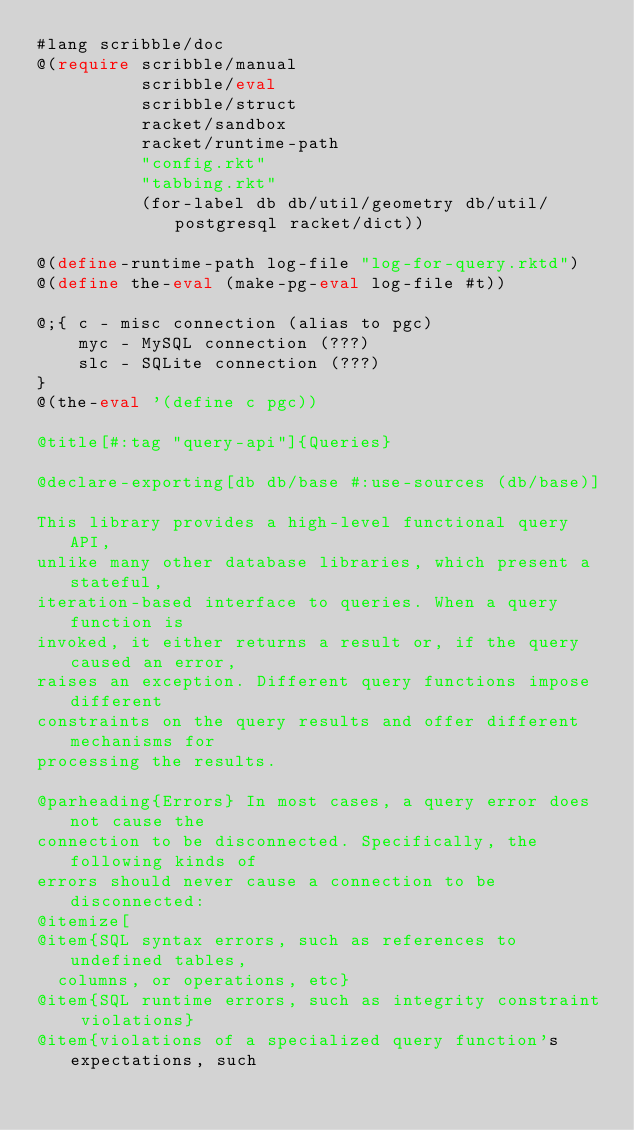<code> <loc_0><loc_0><loc_500><loc_500><_Racket_>#lang scribble/doc
@(require scribble/manual
          scribble/eval
          scribble/struct
          racket/sandbox
          racket/runtime-path
          "config.rkt"
          "tabbing.rkt"
          (for-label db db/util/geometry db/util/postgresql racket/dict))

@(define-runtime-path log-file "log-for-query.rktd")
@(define the-eval (make-pg-eval log-file #t))

@;{ c - misc connection (alias to pgc)
    myc - MySQL connection (???)
    slc - SQLite connection (???)
}
@(the-eval '(define c pgc))

@title[#:tag "query-api"]{Queries}

@declare-exporting[db db/base #:use-sources (db/base)]

This library provides a high-level functional query API,
unlike many other database libraries, which present a stateful,
iteration-based interface to queries. When a query function is
invoked, it either returns a result or, if the query caused an error,
raises an exception. Different query functions impose different
constraints on the query results and offer different mechanisms for
processing the results.

@parheading{Errors} In most cases, a query error does not cause the
connection to be disconnected. Specifically, the following kinds of
errors should never cause a connection to be disconnected:
@itemize[
@item{SQL syntax errors, such as references to undefined tables,
  columns, or operations, etc}
@item{SQL runtime errors, such as integrity constraint violations}
@item{violations of a specialized query function's expectations, such</code> 